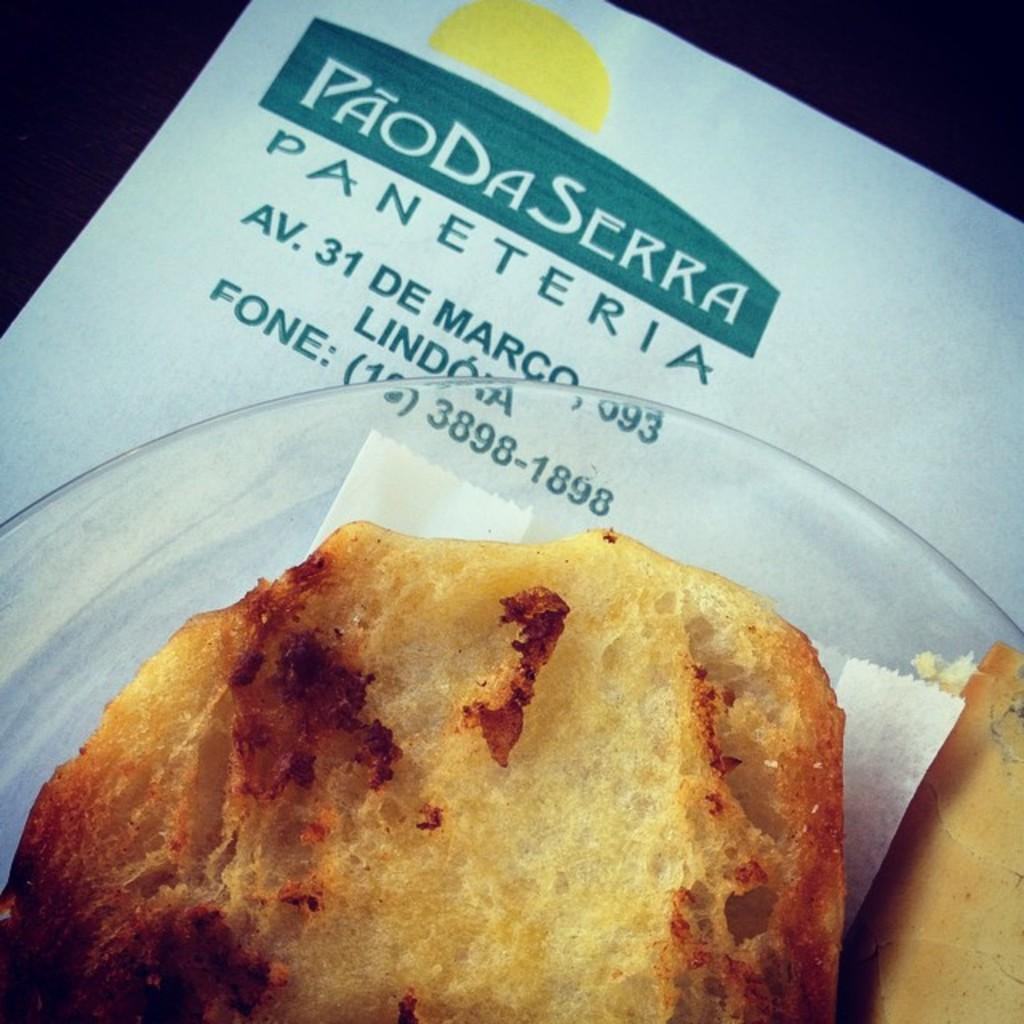What is the main subject of the image? There is a food item in the image. How is the food item placed in the image? The food item is on a tissue paper. What is the tissue paper placed on? The tissue paper is in a plate. Where is the plate located in the image? The plate is on a poster. What level of disgust can be observed in the image? There is no indication of disgust in the image; it simply shows a food item on a tissue paper in a plate on a poster. 